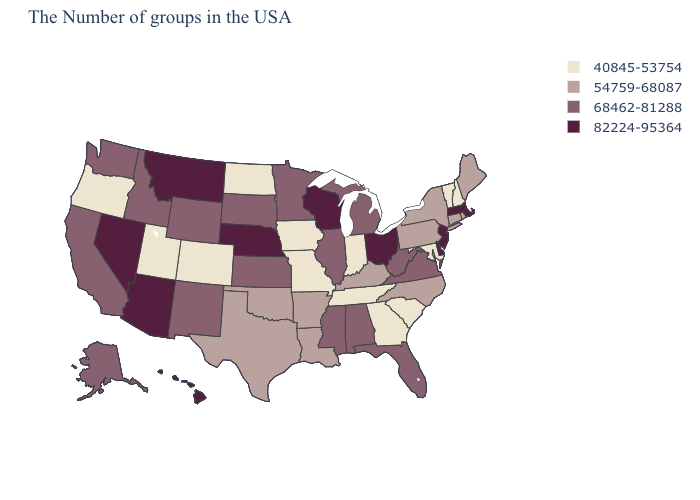Name the states that have a value in the range 54759-68087?
Quick response, please. Maine, Rhode Island, Connecticut, New York, Pennsylvania, North Carolina, Kentucky, Louisiana, Arkansas, Oklahoma, Texas. Among the states that border Michigan , which have the lowest value?
Keep it brief. Indiana. What is the highest value in the USA?
Give a very brief answer. 82224-95364. Does the map have missing data?
Write a very short answer. No. What is the value of Utah?
Short answer required. 40845-53754. Does Maine have the lowest value in the USA?
Quick response, please. No. Name the states that have a value in the range 54759-68087?
Keep it brief. Maine, Rhode Island, Connecticut, New York, Pennsylvania, North Carolina, Kentucky, Louisiana, Arkansas, Oklahoma, Texas. Name the states that have a value in the range 68462-81288?
Give a very brief answer. Virginia, West Virginia, Florida, Michigan, Alabama, Illinois, Mississippi, Minnesota, Kansas, South Dakota, Wyoming, New Mexico, Idaho, California, Washington, Alaska. Among the states that border Minnesota , which have the highest value?
Short answer required. Wisconsin. What is the value of New Hampshire?
Concise answer only. 40845-53754. Does Pennsylvania have the highest value in the Northeast?
Quick response, please. No. What is the lowest value in the USA?
Give a very brief answer. 40845-53754. Which states have the lowest value in the USA?
Answer briefly. New Hampshire, Vermont, Maryland, South Carolina, Georgia, Indiana, Tennessee, Missouri, Iowa, North Dakota, Colorado, Utah, Oregon. What is the highest value in the West ?
Write a very short answer. 82224-95364. Name the states that have a value in the range 82224-95364?
Concise answer only. Massachusetts, New Jersey, Delaware, Ohio, Wisconsin, Nebraska, Montana, Arizona, Nevada, Hawaii. 